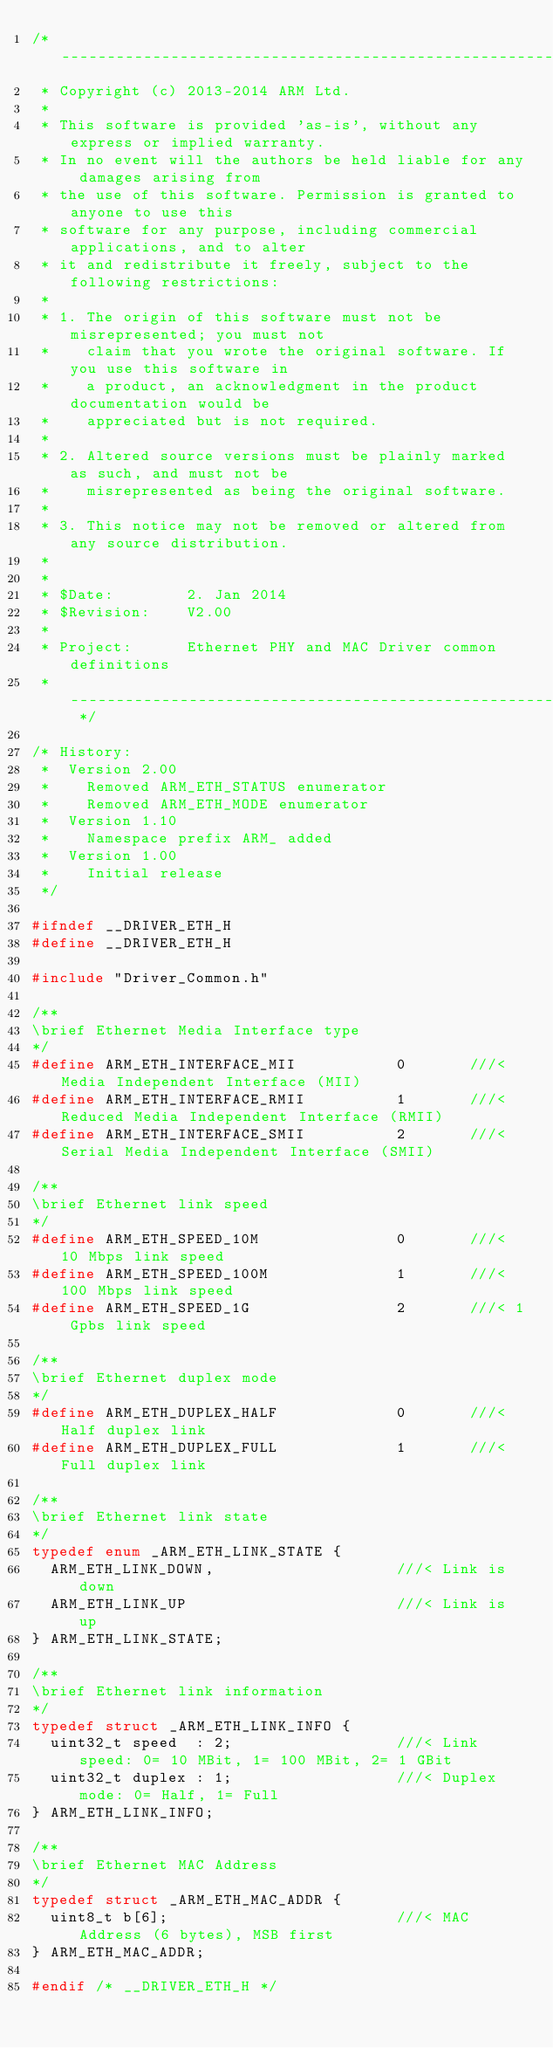Convert code to text. <code><loc_0><loc_0><loc_500><loc_500><_C_>/* -----------------------------------------------------------------------------
 * Copyright (c) 2013-2014 ARM Ltd.
 *
 * This software is provided 'as-is', without any express or implied warranty.
 * In no event will the authors be held liable for any damages arising from
 * the use of this software. Permission is granted to anyone to use this
 * software for any purpose, including commercial applications, and to alter
 * it and redistribute it freely, subject to the following restrictions:
 *
 * 1. The origin of this software must not be misrepresented; you must not
 *    claim that you wrote the original software. If you use this software in
 *    a product, an acknowledgment in the product documentation would be
 *    appreciated but is not required.
 *
 * 2. Altered source versions must be plainly marked as such, and must not be
 *    misrepresented as being the original software.
 *
 * 3. This notice may not be removed or altered from any source distribution.
 *
 *
 * $Date:        2. Jan 2014
 * $Revision:    V2.00
 *
 * Project:      Ethernet PHY and MAC Driver common definitions
 * -------------------------------------------------------------------------- */

/* History:
 *  Version 2.00
 *    Removed ARM_ETH_STATUS enumerator
 *    Removed ARM_ETH_MODE enumerator
 *  Version 1.10
 *    Namespace prefix ARM_ added
 *  Version 1.00
 *    Initial release
 */ 

#ifndef __DRIVER_ETH_H
#define __DRIVER_ETH_H

#include "Driver_Common.h"

/**
\brief Ethernet Media Interface type
*/
#define ARM_ETH_INTERFACE_MII           0       ///< Media Independent Interface (MII)
#define ARM_ETH_INTERFACE_RMII          1       ///< Reduced Media Independent Interface (RMII)
#define ARM_ETH_INTERFACE_SMII          2       ///< Serial Media Independent Interface (SMII)

/**
\brief Ethernet link speed
*/
#define ARM_ETH_SPEED_10M               0       ///< 10 Mbps link speed
#define ARM_ETH_SPEED_100M              1       ///< 100 Mbps link speed
#define ARM_ETH_SPEED_1G                2       ///< 1 Gpbs link speed

/**
\brief Ethernet duplex mode
*/
#define ARM_ETH_DUPLEX_HALF             0       ///< Half duplex link
#define ARM_ETH_DUPLEX_FULL             1       ///< Full duplex link

/**
\brief Ethernet link state
*/
typedef enum _ARM_ETH_LINK_STATE {
  ARM_ETH_LINK_DOWN,                    ///< Link is down
  ARM_ETH_LINK_UP                       ///< Link is up
} ARM_ETH_LINK_STATE;

/**
\brief Ethernet link information
*/
typedef struct _ARM_ETH_LINK_INFO {
  uint32_t speed  : 2;                  ///< Link speed: 0= 10 MBit, 1= 100 MBit, 2= 1 GBit
  uint32_t duplex : 1;                  ///< Duplex mode: 0= Half, 1= Full
} ARM_ETH_LINK_INFO;

/**
\brief Ethernet MAC Address
*/
typedef struct _ARM_ETH_MAC_ADDR {
  uint8_t b[6];                         ///< MAC Address (6 bytes), MSB first
} ARM_ETH_MAC_ADDR;

#endif /* __DRIVER_ETH_H */
</code> 